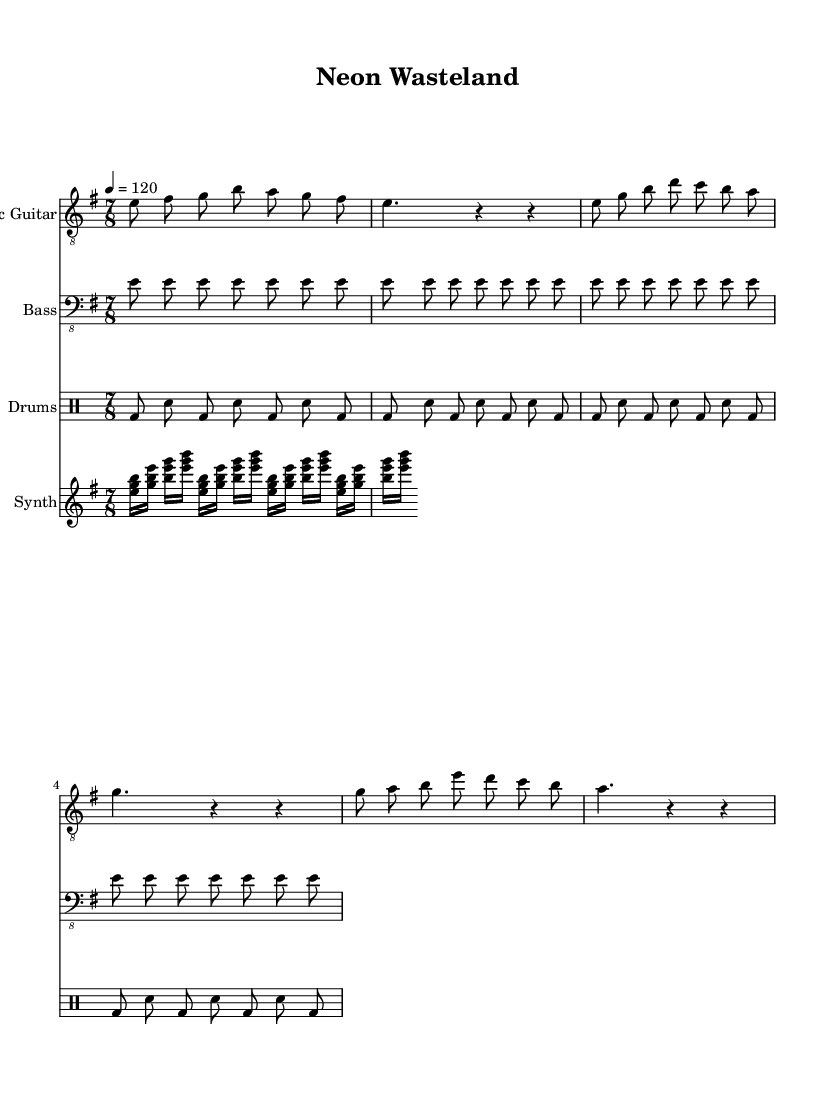What is the key signature of this music? The key signature appears to be E minor, which is indicated by one sharp (F#) in the key signature. This is confirmed by the note "e" in the global variable at the start of the code.
Answer: E minor What is the time signature of this music? The time signature is indicated in the global variable of the code as 7/8. This means there are seven eighth-note beats in each measure.
Answer: 7/8 What is the tempo marking of this piece? The tempo marking is defined in the global variable section with "4 = 120", meaning there are 120 beats per minute, which corresponds to a moderately fast pace for rock music.
Answer: 120 How many measures are in the electric guitar part? The electric guitar part consists of four distinct measures presented in the music code. Each line in this part corresponds to a measure which leads to the total count.
Answer: 4 Which instrument's music includes a synthesizer part? The synthesizer part is presented separately in the score and is listed under its own staff, confirming its inclusion as a dedicated instrument in the arrangement.
Answer: Synthesizer What rhythmic pattern is used for the drums? The drums feature a pattern alternating between bass drum and snare in eighth-note values. This gives the piece a driving rock feel typical for this genre, with the pattern repeating consistently.
Answer: Bass and snare What is the primary mode used in the music? The primary mode used throughout the sections of this music is derived from the E minor scale, reflecting a darker tonality often associated with the themes explored in progressive rock.
Answer: E minor 